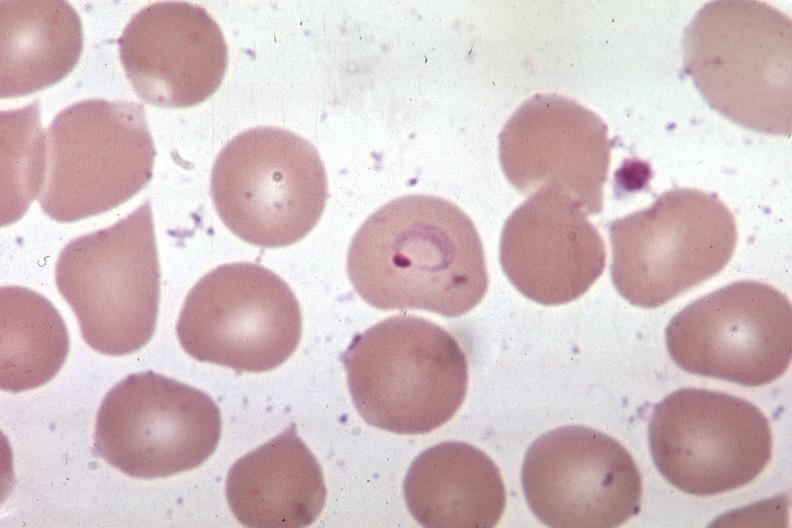does this image show wrights excellent?
Answer the question using a single word or phrase. Yes 